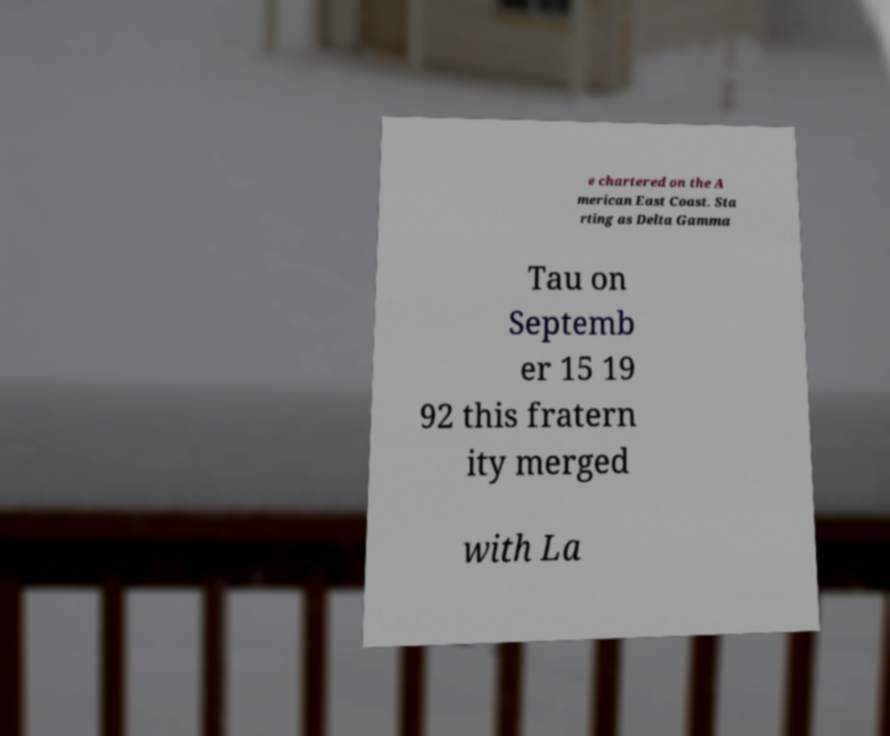Can you accurately transcribe the text from the provided image for me? e chartered on the A merican East Coast. Sta rting as Delta Gamma Tau on Septemb er 15 19 92 this fratern ity merged with La 